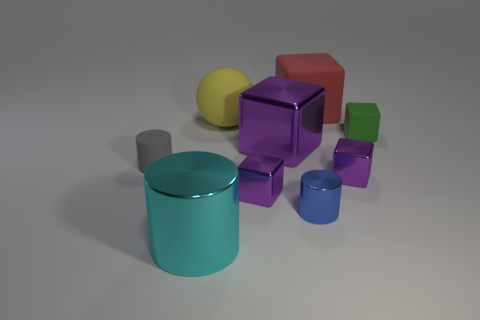The big metallic cylinder is what color?
Your answer should be very brief. Cyan. Does the big rubber block have the same color as the large matte ball?
Ensure brevity in your answer.  No. There is a tiny thing left of the cylinder that is in front of the tiny cylinder to the right of the big cyan thing; what color is it?
Give a very brief answer. Gray. How many green objects are small objects or tiny blocks?
Provide a succinct answer. 1. How many tiny matte objects are the same shape as the large red object?
Keep it short and to the point. 1. What shape is the purple metal thing that is the same size as the yellow ball?
Offer a terse response. Cube. There is a gray matte cylinder; are there any shiny blocks behind it?
Your answer should be compact. Yes. Is there a purple metal block in front of the large shiny object on the right side of the large cyan cylinder?
Your answer should be very brief. Yes. Are there fewer big cyan metal things behind the small blue cylinder than big shiny objects in front of the large purple block?
Your answer should be very brief. Yes. What is the shape of the green object?
Offer a very short reply. Cube. 